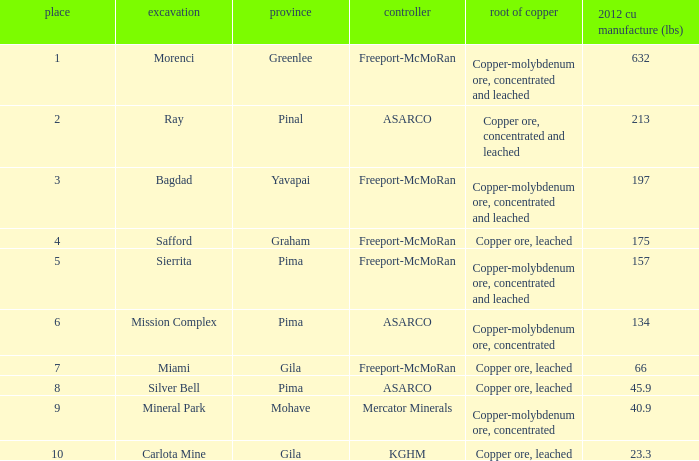What's the name of the operator who has the mission complex mine and has a 2012 Cu Production (lbs) larger than 23.3? ASARCO. 